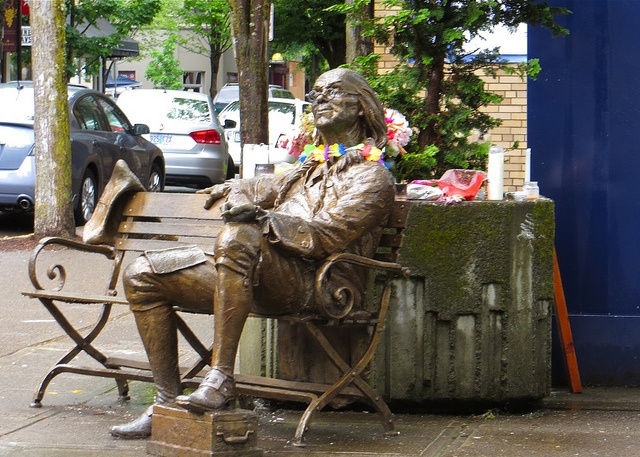Describe the objects in this image and their specific colors. I can see bench in darkgreen, black, darkgray, and lightgray tones, car in darkgreen, black, white, gray, and darkgray tones, car in darkgreen, white, gray, darkgray, and black tones, car in darkgreen, white, gray, and darkgray tones, and car in darkgreen, lavender, gray, and darkgray tones in this image. 